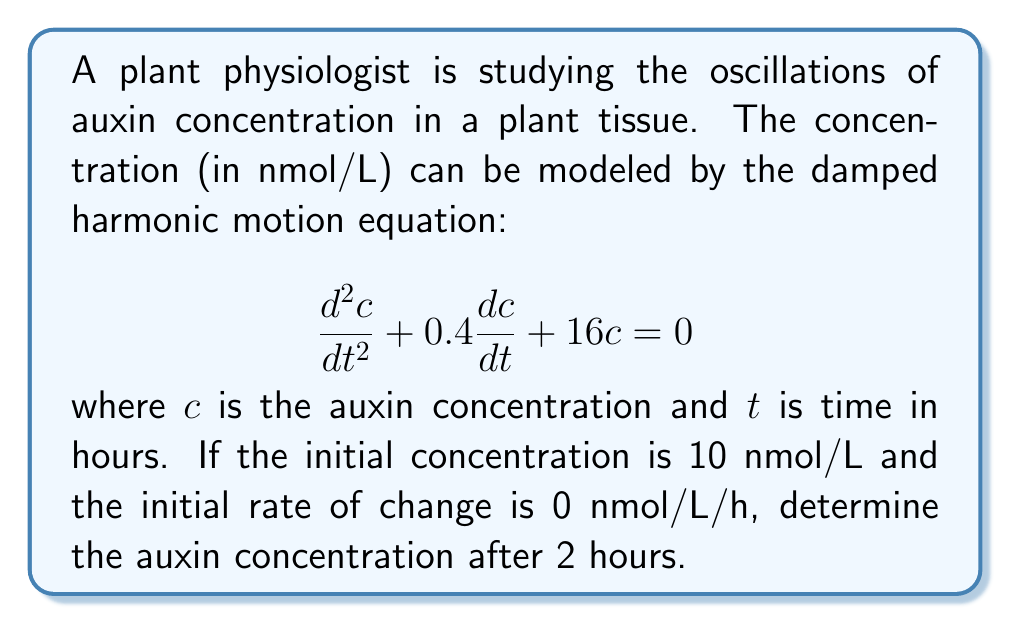Help me with this question. 1) The general solution for this second-order linear differential equation is:

   $$c(t) = e^{-\frac{bt}{2}}(A\cos(\omega t) + B\sin(\omega t))$$

   where $b = 0.4$ and $\omega = \sqrt{16 - (\frac{b}{2})^2} = \sqrt{15.96} \approx 3.995$

2) Using the initial conditions:
   At $t = 0$, $c(0) = 10$ and $\frac{dc}{dt}(0) = 0$

3) From $c(0) = 10$:
   $$10 = A$$

4) From $\frac{dc}{dt}(0) = 0$:
   $$0 = -\frac{b}{2}A + B\omega$$
   $$B = \frac{0.4 \cdot 10}{2 \cdot 3.995} \approx 0.5006$$

5) Therefore, the solution is:
   $$c(t) = e^{-0.2t}(10\cos(3.995t) + 0.5006\sin(3.995t))$$

6) To find the concentration at $t = 2$ hours, substitute $t = 2$:
   $$c(2) = e^{-0.4}(10\cos(7.99) + 0.5006\sin(7.99))$$

7) Calculating this:
   $$c(2) \approx 0.6703 \cdot (-6.2731 + 0.3133) \approx -3.9891$$
Answer: $-3.99$ nmol/L 